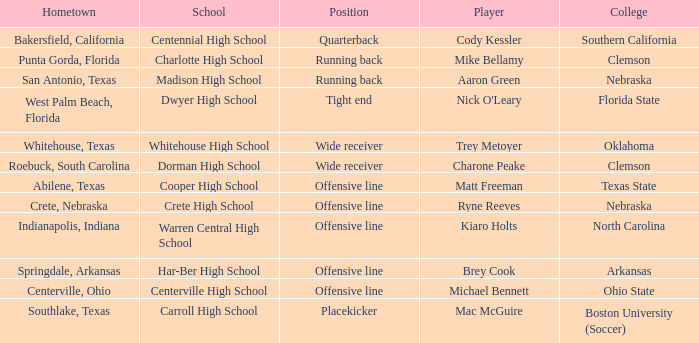What college did the placekicker go to? Boston University (Soccer). Can you parse all the data within this table? {'header': ['Hometown', 'School', 'Position', 'Player', 'College'], 'rows': [['Bakersfield, California', 'Centennial High School', 'Quarterback', 'Cody Kessler', 'Southern California'], ['Punta Gorda, Florida', 'Charlotte High School', 'Running back', 'Mike Bellamy', 'Clemson'], ['San Antonio, Texas', 'Madison High School', 'Running back', 'Aaron Green', 'Nebraska'], ['West Palm Beach, Florida', 'Dwyer High School', 'Tight end', "Nick O'Leary", 'Florida State'], ['Whitehouse, Texas', 'Whitehouse High School', 'Wide receiver', 'Trey Metoyer', 'Oklahoma'], ['Roebuck, South Carolina', 'Dorman High School', 'Wide receiver', 'Charone Peake', 'Clemson'], ['Abilene, Texas', 'Cooper High School', 'Offensive line', 'Matt Freeman', 'Texas State'], ['Crete, Nebraska', 'Crete High School', 'Offensive line', 'Ryne Reeves', 'Nebraska'], ['Indianapolis, Indiana', 'Warren Central High School', 'Offensive line', 'Kiaro Holts', 'North Carolina'], ['Springdale, Arkansas', 'Har-Ber High School', 'Offensive line', 'Brey Cook', 'Arkansas'], ['Centerville, Ohio', 'Centerville High School', 'Offensive line', 'Michael Bennett', 'Ohio State'], ['Southlake, Texas', 'Carroll High School', 'Placekicker', 'Mac McGuire', 'Boston University (Soccer)']]} 